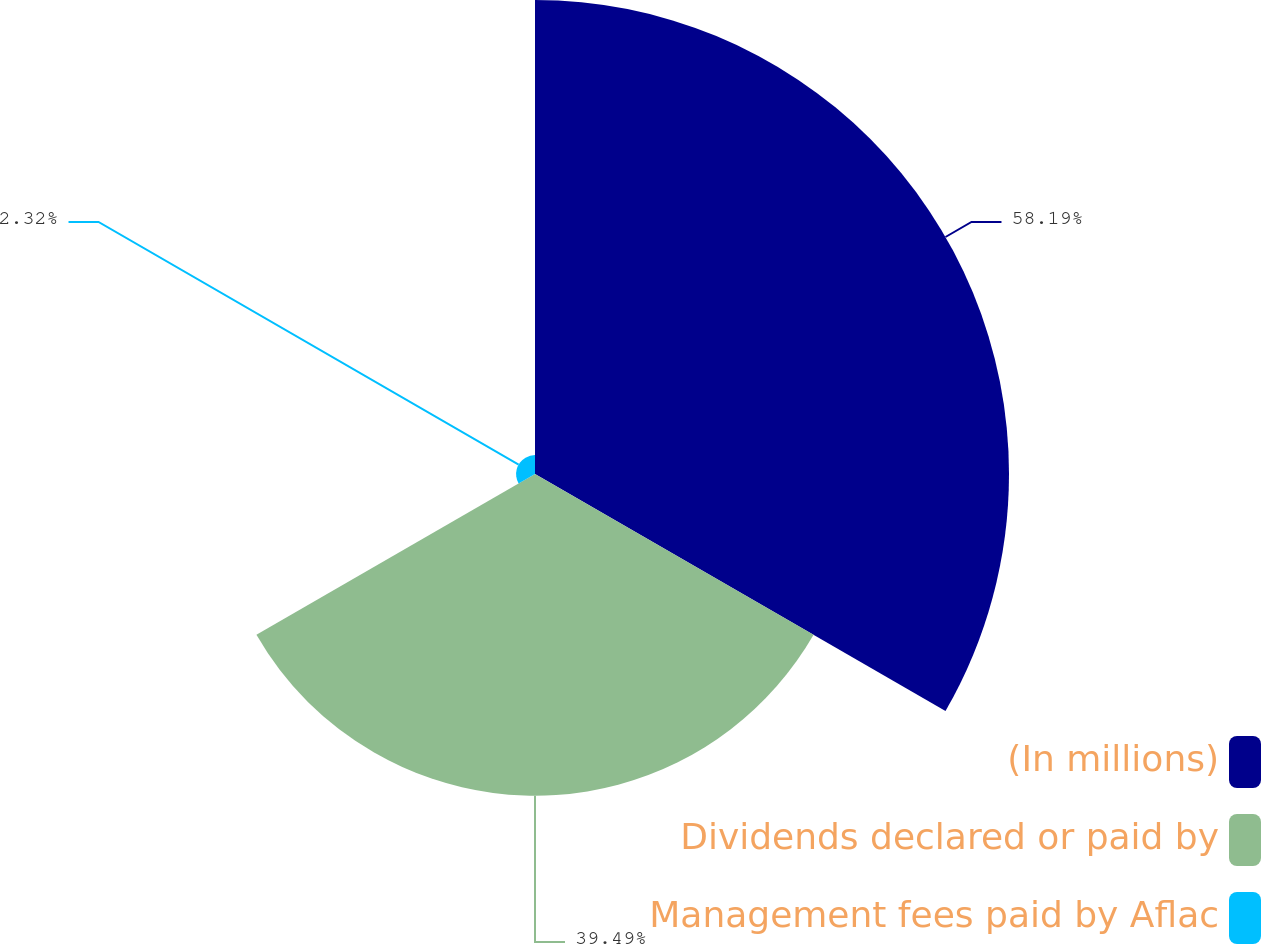Convert chart to OTSL. <chart><loc_0><loc_0><loc_500><loc_500><pie_chart><fcel>(In millions)<fcel>Dividends declared or paid by<fcel>Management fees paid by Aflac<nl><fcel>58.19%<fcel>39.49%<fcel>2.32%<nl></chart> 